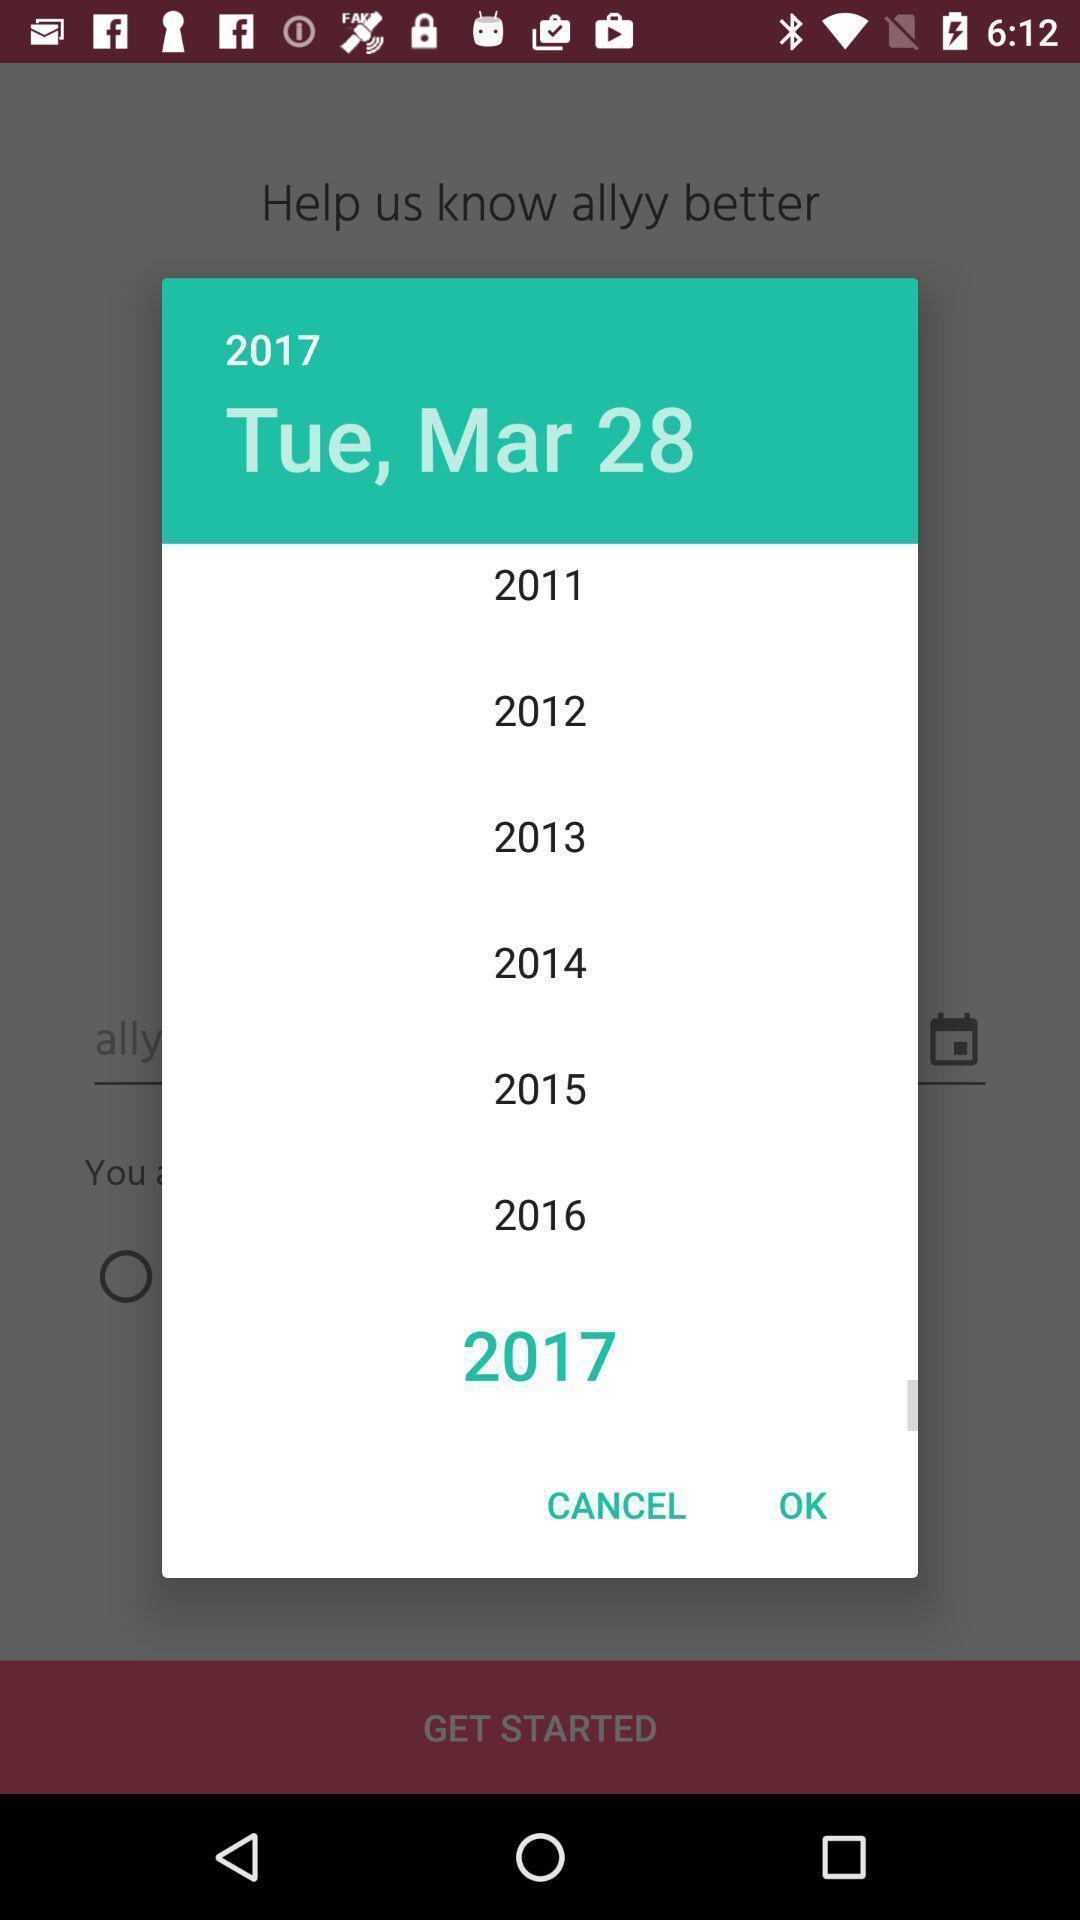Describe the content in this image. Pop-up to select the date. 